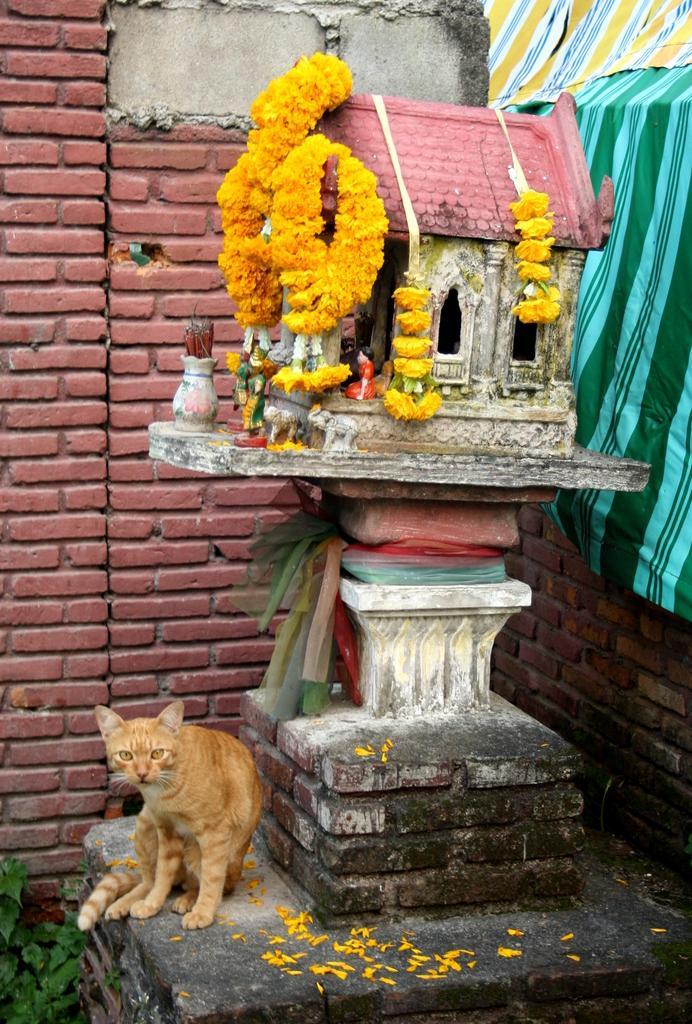Describe this image in one or two sentences. Bottom of the image there is cat. In the middle of the image there is a statue and there are some flowers. Behind the statue there is wall. 